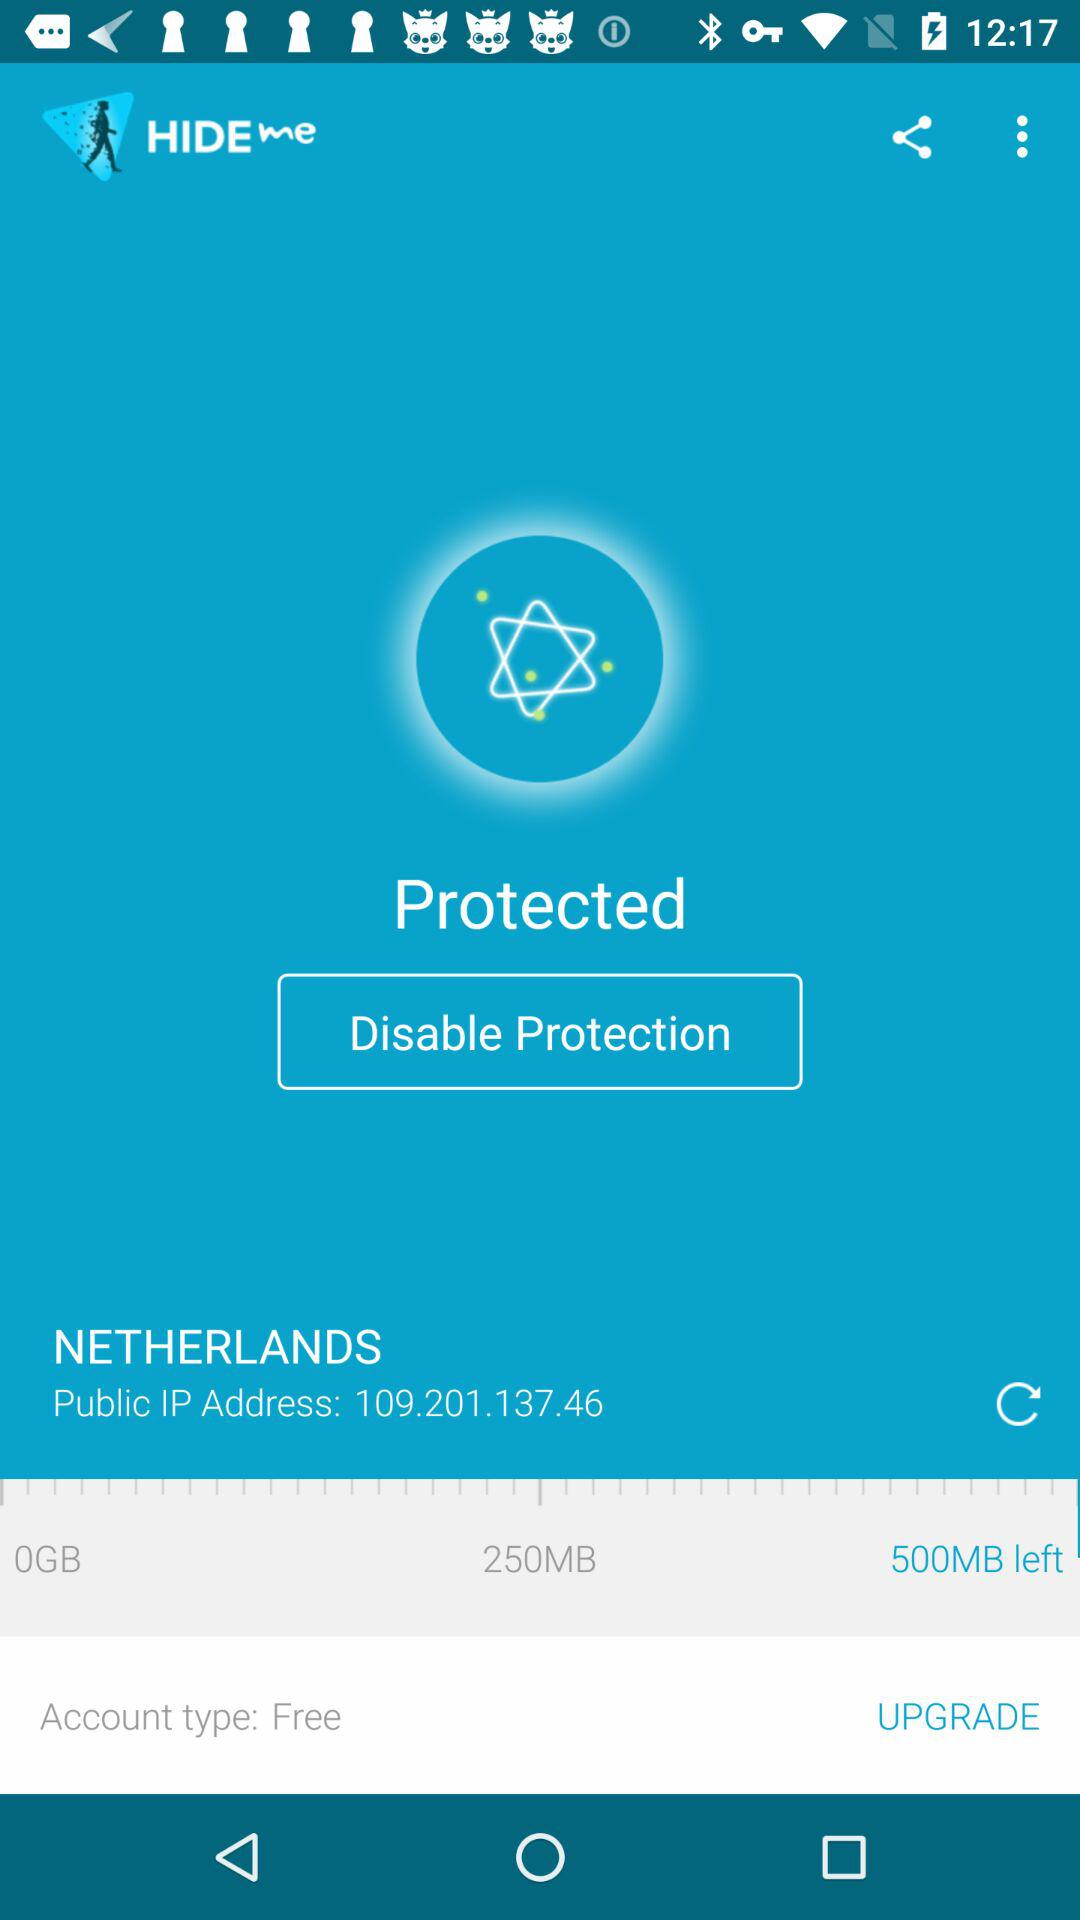What is the IP address? The IP address is 109.201.137.46. 